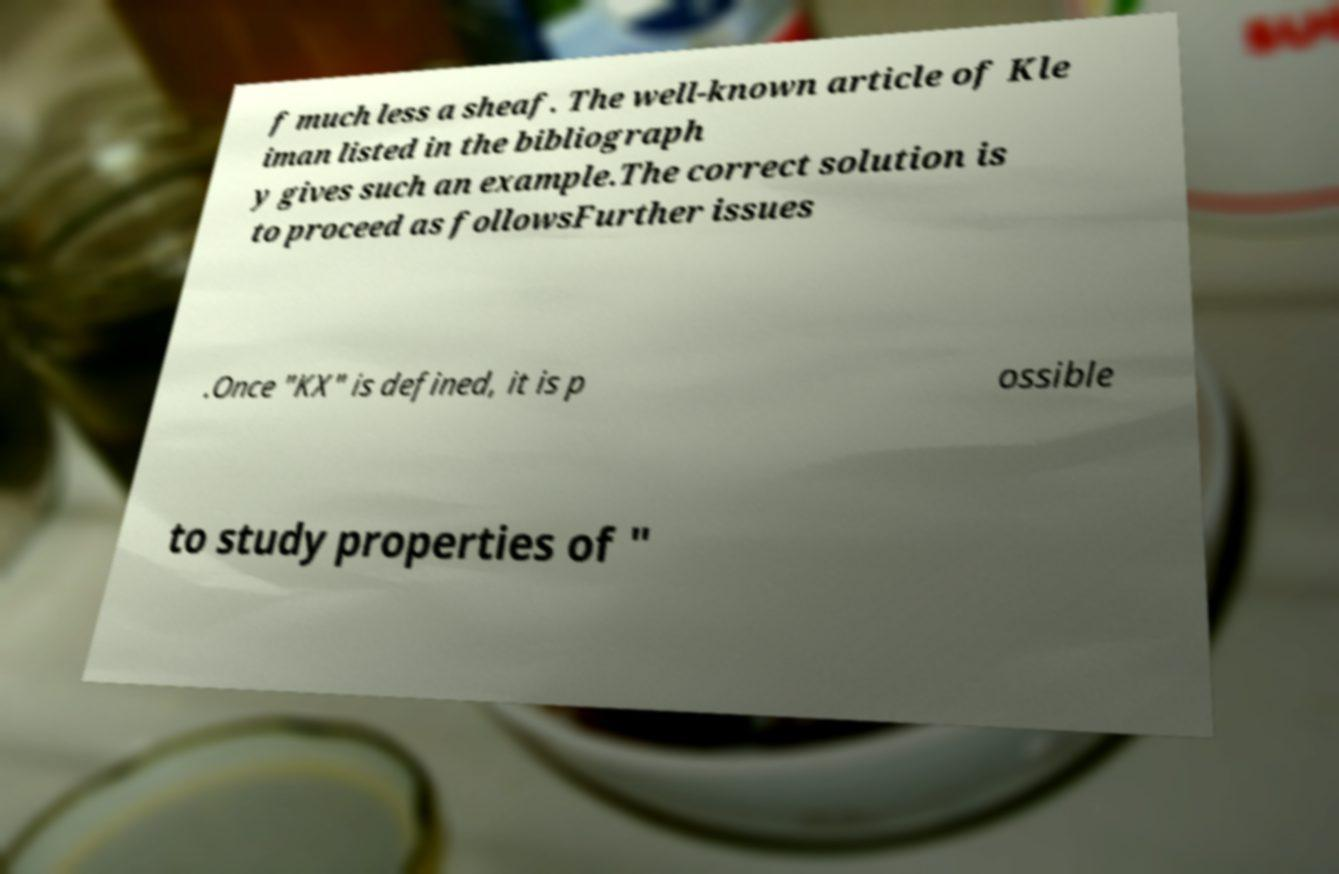I need the written content from this picture converted into text. Can you do that? f much less a sheaf. The well-known article of Kle iman listed in the bibliograph y gives such an example.The correct solution is to proceed as followsFurther issues .Once "KX" is defined, it is p ossible to study properties of " 